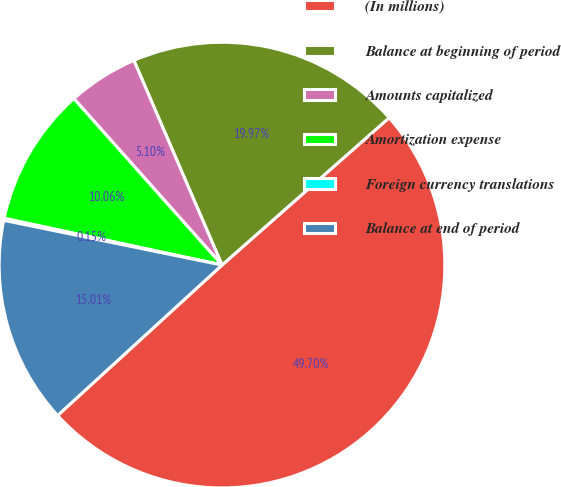Convert chart to OTSL. <chart><loc_0><loc_0><loc_500><loc_500><pie_chart><fcel>(In millions)<fcel>Balance at beginning of period<fcel>Amounts capitalized<fcel>Amortization expense<fcel>Foreign currency translations<fcel>Balance at end of period<nl><fcel>49.7%<fcel>19.97%<fcel>5.1%<fcel>10.06%<fcel>0.15%<fcel>15.01%<nl></chart> 